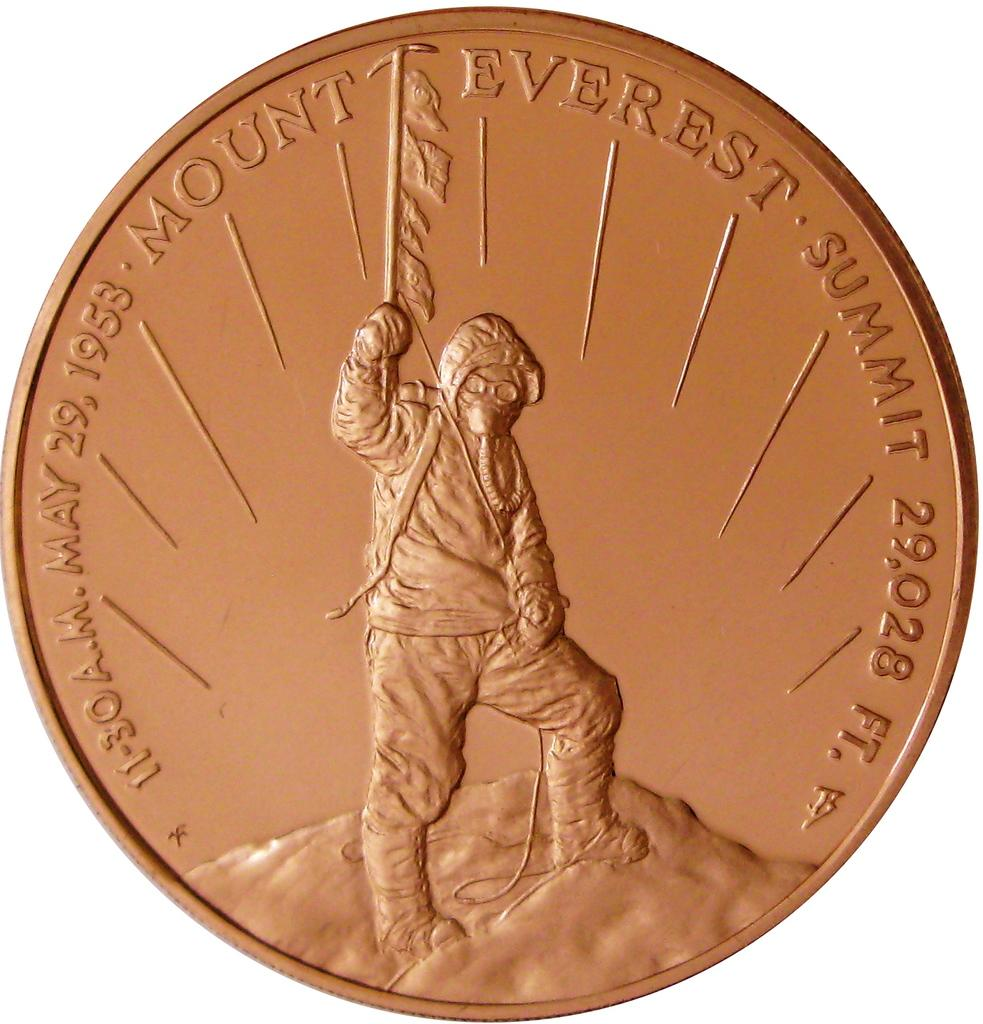<image>
Relay a brief, clear account of the picture shown. A bronze coin depicting the reaching of the summit of Everest in 1953 